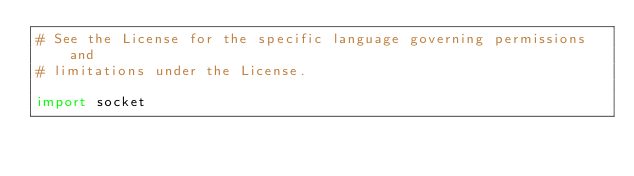<code> <loc_0><loc_0><loc_500><loc_500><_Python_># See the License for the specific language governing permissions and
# limitations under the License.

import socket</code> 